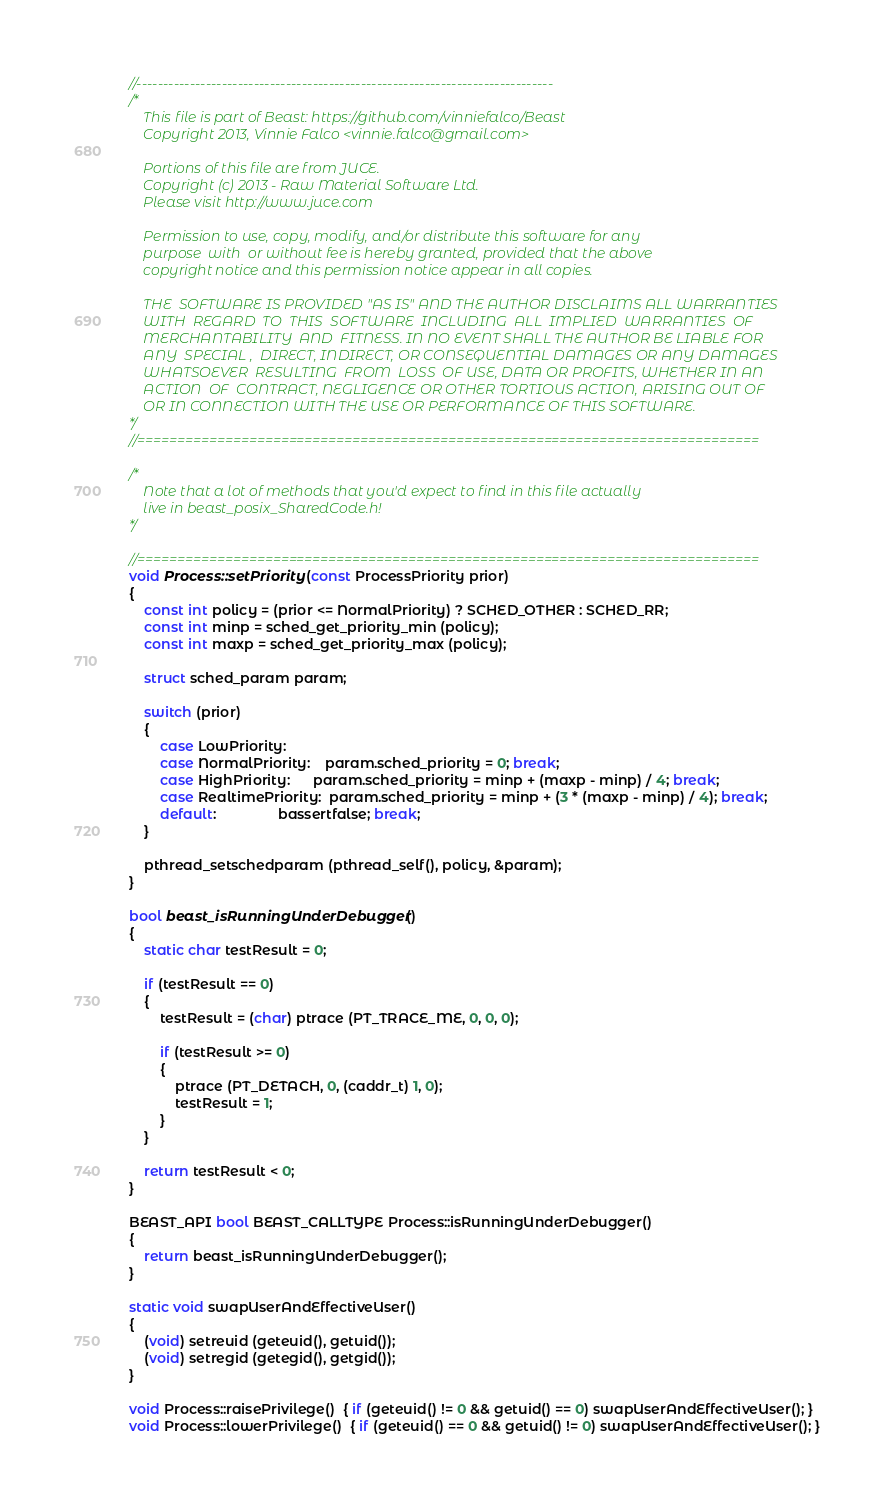<code> <loc_0><loc_0><loc_500><loc_500><_C++_>//------------------------------------------------------------------------------
/*
    This file is part of Beast: https://github.com/vinniefalco/Beast
    Copyright 2013, Vinnie Falco <vinnie.falco@gmail.com>

    Portions of this file are from JUCE.
    Copyright (c) 2013 - Raw Material Software Ltd.
    Please visit http://www.juce.com

    Permission to use, copy, modify, and/or distribute this software for any
    purpose  with  or without fee is hereby granted, provided that the above
    copyright notice and this permission notice appear in all copies.

    THE  SOFTWARE IS PROVIDED "AS IS" AND THE AUTHOR DISCLAIMS ALL WARRANTIES
    WITH  REGARD  TO  THIS  SOFTWARE  INCLUDING  ALL  IMPLIED  WARRANTIES  OF
    MERCHANTABILITY  AND  FITNESS. IN NO EVENT SHALL THE AUTHOR BE LIABLE FOR
    ANY  SPECIAL ,  DIRECT, INDIRECT, OR CONSEQUENTIAL DAMAGES OR ANY DAMAGES
    WHATSOEVER  RESULTING  FROM  LOSS  OF USE, DATA OR PROFITS, WHETHER IN AN
    ACTION  OF  CONTRACT, NEGLIGENCE OR OTHER TORTIOUS ACTION, ARISING OUT OF
    OR IN CONNECTION WITH THE USE OR PERFORMANCE OF THIS SOFTWARE.
*/
//==============================================================================

/*
    Note that a lot of methods that you'd expect to find in this file actually
    live in beast_posix_SharedCode.h!
*/

//==============================================================================
void Process::setPriority (const ProcessPriority prior)
{
    const int policy = (prior <= NormalPriority) ? SCHED_OTHER : SCHED_RR;
    const int minp = sched_get_priority_min (policy);
    const int maxp = sched_get_priority_max (policy);

    struct sched_param param;

    switch (prior)
    {
        case LowPriority:
        case NormalPriority:    param.sched_priority = 0; break;
        case HighPriority:      param.sched_priority = minp + (maxp - minp) / 4; break;
        case RealtimePriority:  param.sched_priority = minp + (3 * (maxp - minp) / 4); break;
        default:                bassertfalse; break;
    }

    pthread_setschedparam (pthread_self(), policy, &param);
}

bool beast_isRunningUnderDebugger()
{
    static char testResult = 0;

    if (testResult == 0)
    {
        testResult = (char) ptrace (PT_TRACE_ME, 0, 0, 0);

        if (testResult >= 0)
        {
            ptrace (PT_DETACH, 0, (caddr_t) 1, 0);
            testResult = 1;
        }
    }

    return testResult < 0;
}

BEAST_API bool BEAST_CALLTYPE Process::isRunningUnderDebugger()
{
    return beast_isRunningUnderDebugger();
}

static void swapUserAndEffectiveUser()
{
    (void) setreuid (geteuid(), getuid());
    (void) setregid (getegid(), getgid());
}

void Process::raisePrivilege()  { if (geteuid() != 0 && getuid() == 0) swapUserAndEffectiveUser(); }
void Process::lowerPrivilege()  { if (geteuid() == 0 && getuid() != 0) swapUserAndEffectiveUser(); }
</code> 